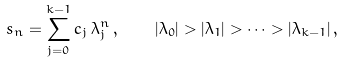<formula> <loc_0><loc_0><loc_500><loc_500>s _ { n } = \sum _ { j = 0 } ^ { k - 1 } c _ { j } \, \lambda ^ { n } _ { j } \, , \quad | \lambda _ { 0 } | > | \lambda _ { 1 } | > \dots > | \lambda _ { k - 1 } | \, ,</formula> 